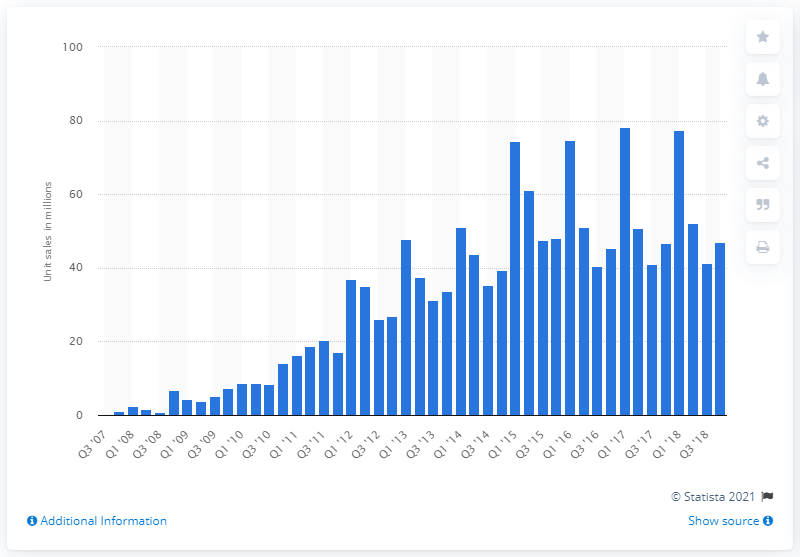Identify some key points in this picture. In the fourth quarter of 2018, a total of 46.89 million iPhones were sold worldwide. 